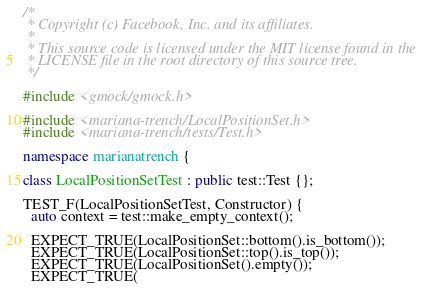Convert code to text. <code><loc_0><loc_0><loc_500><loc_500><_C++_>/*
 * Copyright (c) Facebook, Inc. and its affiliates.
 *
 * This source code is licensed under the MIT license found in the
 * LICENSE file in the root directory of this source tree.
 */

#include <gmock/gmock.h>

#include <mariana-trench/LocalPositionSet.h>
#include <mariana-trench/tests/Test.h>

namespace marianatrench {

class LocalPositionSetTest : public test::Test {};

TEST_F(LocalPositionSetTest, Constructor) {
  auto context = test::make_empty_context();

  EXPECT_TRUE(LocalPositionSet::bottom().is_bottom());
  EXPECT_TRUE(LocalPositionSet::top().is_top());
  EXPECT_TRUE(LocalPositionSet().empty());
  EXPECT_TRUE(</code> 